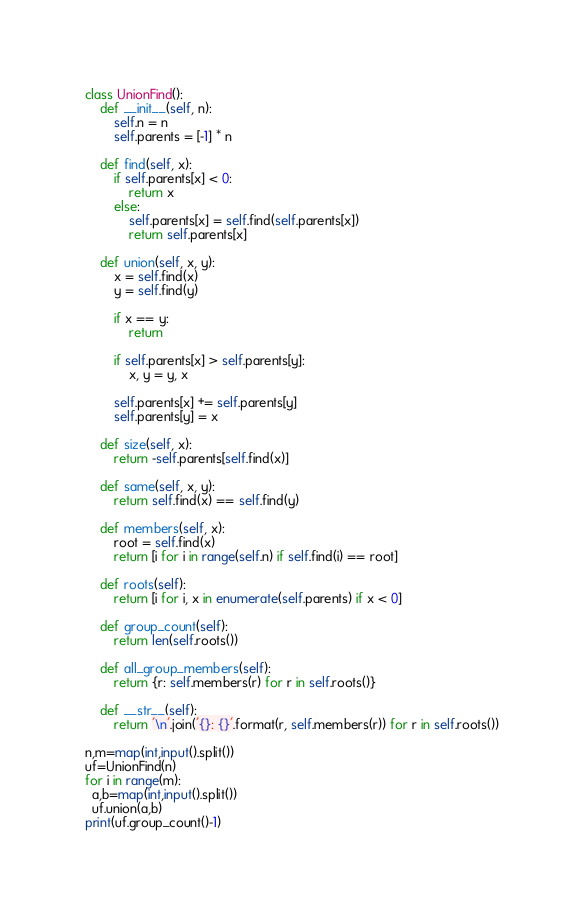<code> <loc_0><loc_0><loc_500><loc_500><_Python_>class UnionFind():
    def __init__(self, n):
        self.n = n
        self.parents = [-1] * n

    def find(self, x):
        if self.parents[x] < 0:
            return x
        else:
            self.parents[x] = self.find(self.parents[x])
            return self.parents[x]

    def union(self, x, y):
        x = self.find(x)
        y = self.find(y)

        if x == y:
            return

        if self.parents[x] > self.parents[y]:
            x, y = y, x

        self.parents[x] += self.parents[y]
        self.parents[y] = x

    def size(self, x):
        return -self.parents[self.find(x)]

    def same(self, x, y):
        return self.find(x) == self.find(y)

    def members(self, x):
        root = self.find(x)
        return [i for i in range(self.n) if self.find(i) == root]

    def roots(self):
        return [i for i, x in enumerate(self.parents) if x < 0]

    def group_count(self):
        return len(self.roots())

    def all_group_members(self):
        return {r: self.members(r) for r in self.roots()}

    def __str__(self):
        return '\n'.join('{}: {}'.format(r, self.members(r)) for r in self.roots())

n,m=map(int,input().split())
uf=UnionFind(n)
for i in range(m):
  a,b=map(int,input().split())
  uf.union(a,b)
print(uf.group_count()-1)</code> 